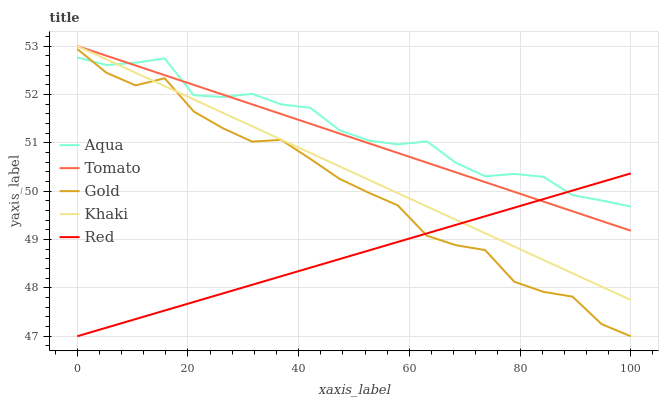Does Red have the minimum area under the curve?
Answer yes or no. Yes. Does Aqua have the maximum area under the curve?
Answer yes or no. Yes. Does Khaki have the minimum area under the curve?
Answer yes or no. No. Does Khaki have the maximum area under the curve?
Answer yes or no. No. Is Tomato the smoothest?
Answer yes or no. Yes. Is Gold the roughest?
Answer yes or no. Yes. Is Khaki the smoothest?
Answer yes or no. No. Is Khaki the roughest?
Answer yes or no. No. Does Red have the lowest value?
Answer yes or no. Yes. Does Khaki have the lowest value?
Answer yes or no. No. Does Khaki have the highest value?
Answer yes or no. Yes. Does Aqua have the highest value?
Answer yes or no. No. Is Gold less than Tomato?
Answer yes or no. Yes. Is Tomato greater than Gold?
Answer yes or no. Yes. Does Aqua intersect Gold?
Answer yes or no. Yes. Is Aqua less than Gold?
Answer yes or no. No. Is Aqua greater than Gold?
Answer yes or no. No. Does Gold intersect Tomato?
Answer yes or no. No. 